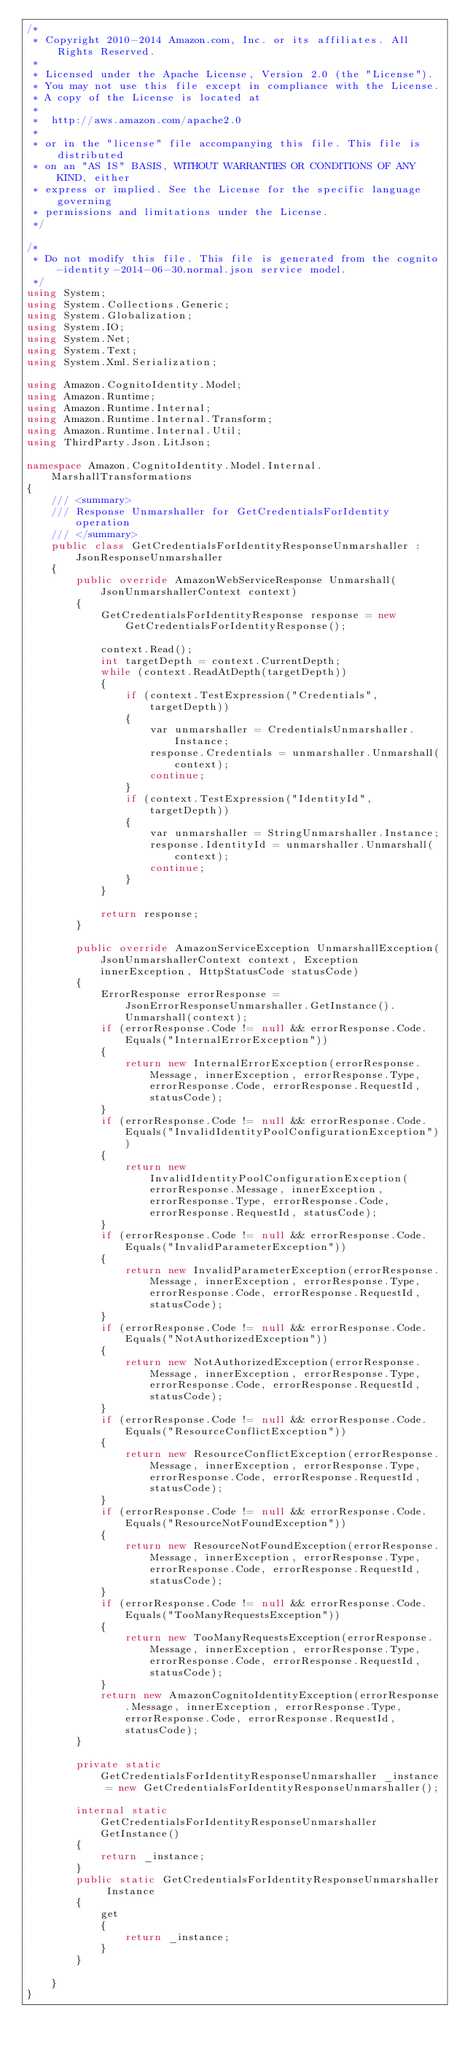Convert code to text. <code><loc_0><loc_0><loc_500><loc_500><_C#_>/*
 * Copyright 2010-2014 Amazon.com, Inc. or its affiliates. All Rights Reserved.
 * 
 * Licensed under the Apache License, Version 2.0 (the "License").
 * You may not use this file except in compliance with the License.
 * A copy of the License is located at
 * 
 *  http://aws.amazon.com/apache2.0
 * 
 * or in the "license" file accompanying this file. This file is distributed
 * on an "AS IS" BASIS, WITHOUT WARRANTIES OR CONDITIONS OF ANY KIND, either
 * express or implied. See the License for the specific language governing
 * permissions and limitations under the License.
 */

/*
 * Do not modify this file. This file is generated from the cognito-identity-2014-06-30.normal.json service model.
 */
using System;
using System.Collections.Generic;
using System.Globalization;
using System.IO;
using System.Net;
using System.Text;
using System.Xml.Serialization;

using Amazon.CognitoIdentity.Model;
using Amazon.Runtime;
using Amazon.Runtime.Internal;
using Amazon.Runtime.Internal.Transform;
using Amazon.Runtime.Internal.Util;
using ThirdParty.Json.LitJson;

namespace Amazon.CognitoIdentity.Model.Internal.MarshallTransformations
{
    /// <summary>
    /// Response Unmarshaller for GetCredentialsForIdentity operation
    /// </summary>  
    public class GetCredentialsForIdentityResponseUnmarshaller : JsonResponseUnmarshaller
    {
        public override AmazonWebServiceResponse Unmarshall(JsonUnmarshallerContext context)
        {
            GetCredentialsForIdentityResponse response = new GetCredentialsForIdentityResponse();

            context.Read();
            int targetDepth = context.CurrentDepth;
            while (context.ReadAtDepth(targetDepth))
            {
                if (context.TestExpression("Credentials", targetDepth))
                {
                    var unmarshaller = CredentialsUnmarshaller.Instance;
                    response.Credentials = unmarshaller.Unmarshall(context);
                    continue;
                }
                if (context.TestExpression("IdentityId", targetDepth))
                {
                    var unmarshaller = StringUnmarshaller.Instance;
                    response.IdentityId = unmarshaller.Unmarshall(context);
                    continue;
                }
            }

            return response;
        }

        public override AmazonServiceException UnmarshallException(JsonUnmarshallerContext context, Exception innerException, HttpStatusCode statusCode)
        {
            ErrorResponse errorResponse = JsonErrorResponseUnmarshaller.GetInstance().Unmarshall(context);
            if (errorResponse.Code != null && errorResponse.Code.Equals("InternalErrorException"))
            {
                return new InternalErrorException(errorResponse.Message, innerException, errorResponse.Type, errorResponse.Code, errorResponse.RequestId, statusCode);
            }
            if (errorResponse.Code != null && errorResponse.Code.Equals("InvalidIdentityPoolConfigurationException"))
            {
                return new InvalidIdentityPoolConfigurationException(errorResponse.Message, innerException, errorResponse.Type, errorResponse.Code, errorResponse.RequestId, statusCode);
            }
            if (errorResponse.Code != null && errorResponse.Code.Equals("InvalidParameterException"))
            {
                return new InvalidParameterException(errorResponse.Message, innerException, errorResponse.Type, errorResponse.Code, errorResponse.RequestId, statusCode);
            }
            if (errorResponse.Code != null && errorResponse.Code.Equals("NotAuthorizedException"))
            {
                return new NotAuthorizedException(errorResponse.Message, innerException, errorResponse.Type, errorResponse.Code, errorResponse.RequestId, statusCode);
            }
            if (errorResponse.Code != null && errorResponse.Code.Equals("ResourceConflictException"))
            {
                return new ResourceConflictException(errorResponse.Message, innerException, errorResponse.Type, errorResponse.Code, errorResponse.RequestId, statusCode);
            }
            if (errorResponse.Code != null && errorResponse.Code.Equals("ResourceNotFoundException"))
            {
                return new ResourceNotFoundException(errorResponse.Message, innerException, errorResponse.Type, errorResponse.Code, errorResponse.RequestId, statusCode);
            }
            if (errorResponse.Code != null && errorResponse.Code.Equals("TooManyRequestsException"))
            {
                return new TooManyRequestsException(errorResponse.Message, innerException, errorResponse.Type, errorResponse.Code, errorResponse.RequestId, statusCode);
            }
            return new AmazonCognitoIdentityException(errorResponse.Message, innerException, errorResponse.Type, errorResponse.Code, errorResponse.RequestId, statusCode);
        }

        private static GetCredentialsForIdentityResponseUnmarshaller _instance = new GetCredentialsForIdentityResponseUnmarshaller();        

        internal static GetCredentialsForIdentityResponseUnmarshaller GetInstance()
        {
            return _instance;
        }
        public static GetCredentialsForIdentityResponseUnmarshaller Instance
        {
            get
            {
                return _instance;
            }
        }

    }
}</code> 